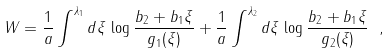<formula> <loc_0><loc_0><loc_500><loc_500>W = \frac { 1 } { a } \int ^ { \lambda _ { 1 } } d \xi \, \log \frac { b _ { 2 } + b _ { 1 } \xi } { g _ { 1 } ( \xi ) } + \frac { 1 } { a } \int ^ { \lambda _ { 2 } } d \xi \, \log \frac { b _ { 2 } + b _ { 1 } \xi } { g _ { 2 } ( \xi ) } \ ,</formula> 